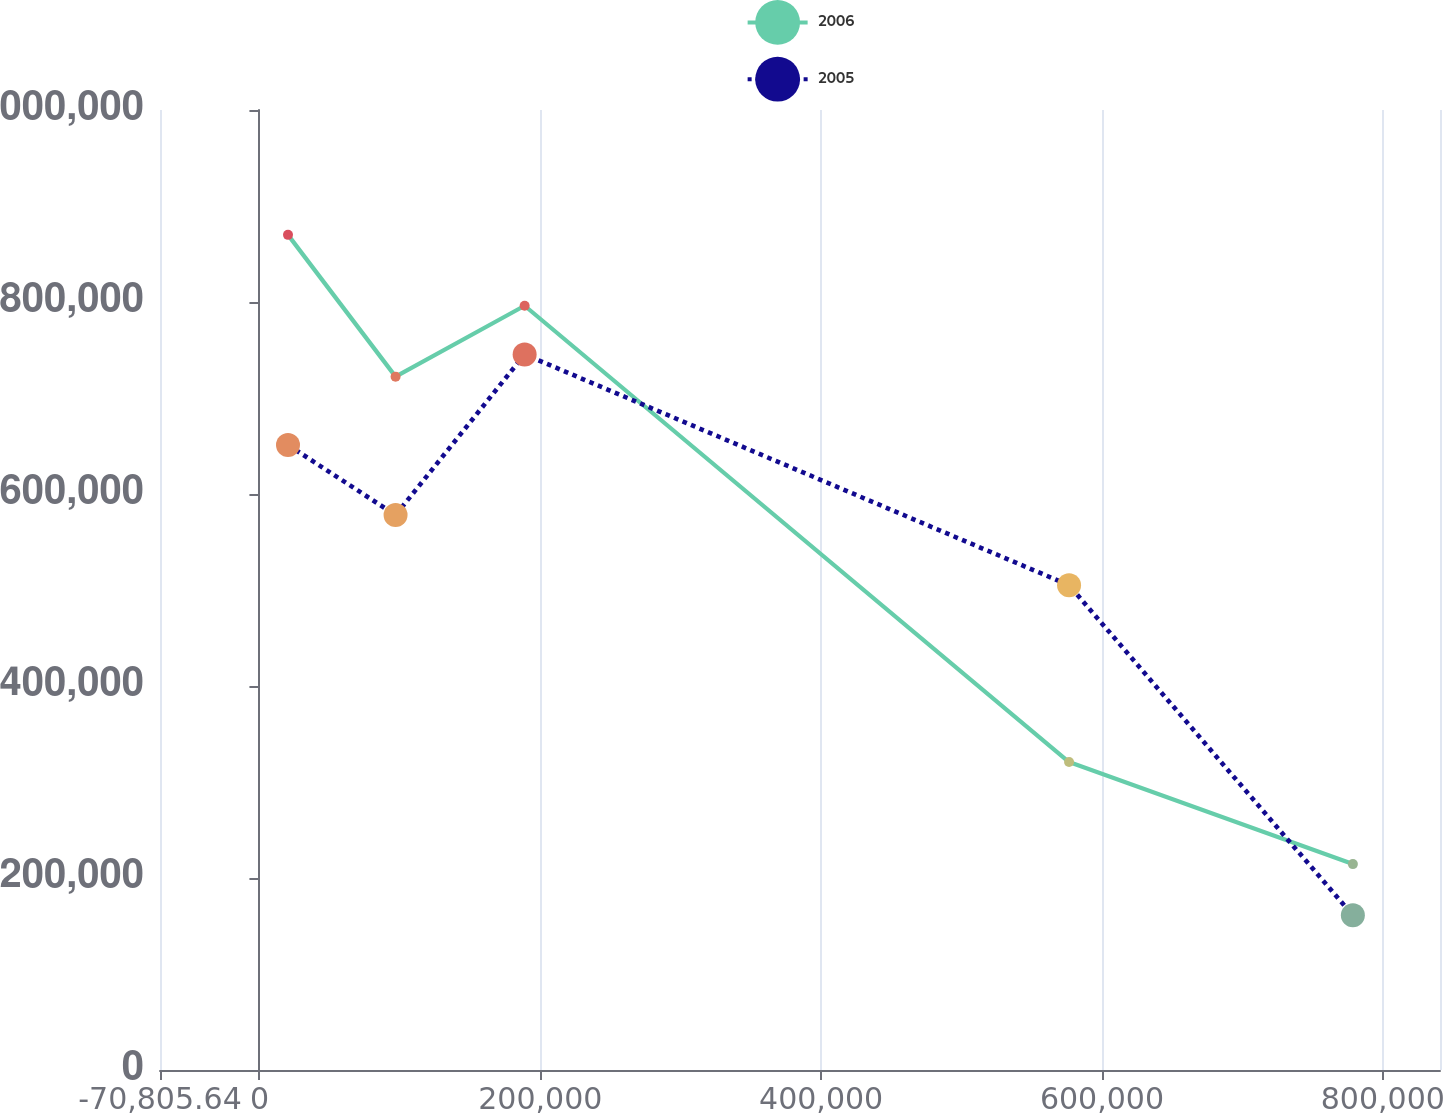Convert chart to OTSL. <chart><loc_0><loc_0><loc_500><loc_500><line_chart><ecel><fcel>2006<fcel>2005<nl><fcel>20347.7<fcel>869931<fcel>651073<nl><fcel>96951.2<fcel>722254<fcel>578036<nl><fcel>188870<fcel>796093<fcel>745405<nl><fcel>576568<fcel>320759<fcel>504999<nl><fcel>778674<fcel>214486<fcel>161108<nl><fcel>855277<fcel>16228.8<fcel>15034<nl><fcel>931881<fcel>140648<fcel>88071.1<nl></chart> 